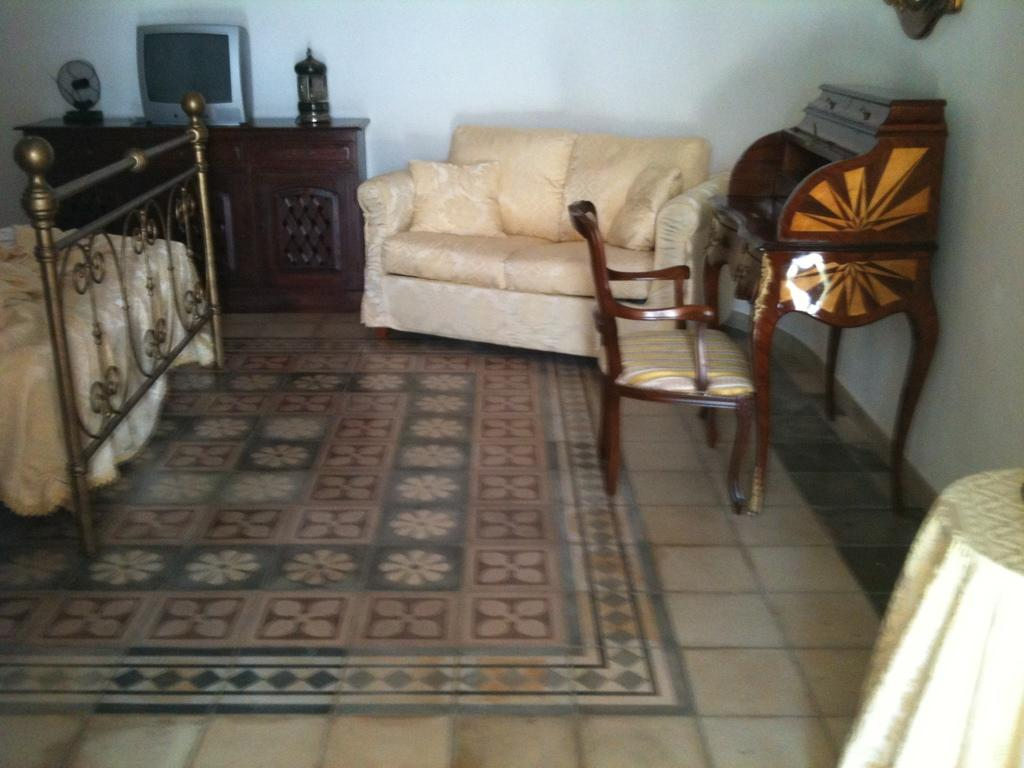What type of space is shown in the image? The image depicts the interior of a room. What furniture is present in the room? There is a chair, a sofa, and a bed in the room. What electronic device can be seen in the room? There is a television in the room. What is on the table in the room? There are items on a table in the room. What type of creature is crawling on the television in the image? There is no creature present in the image, and the television is not being crawled on. 